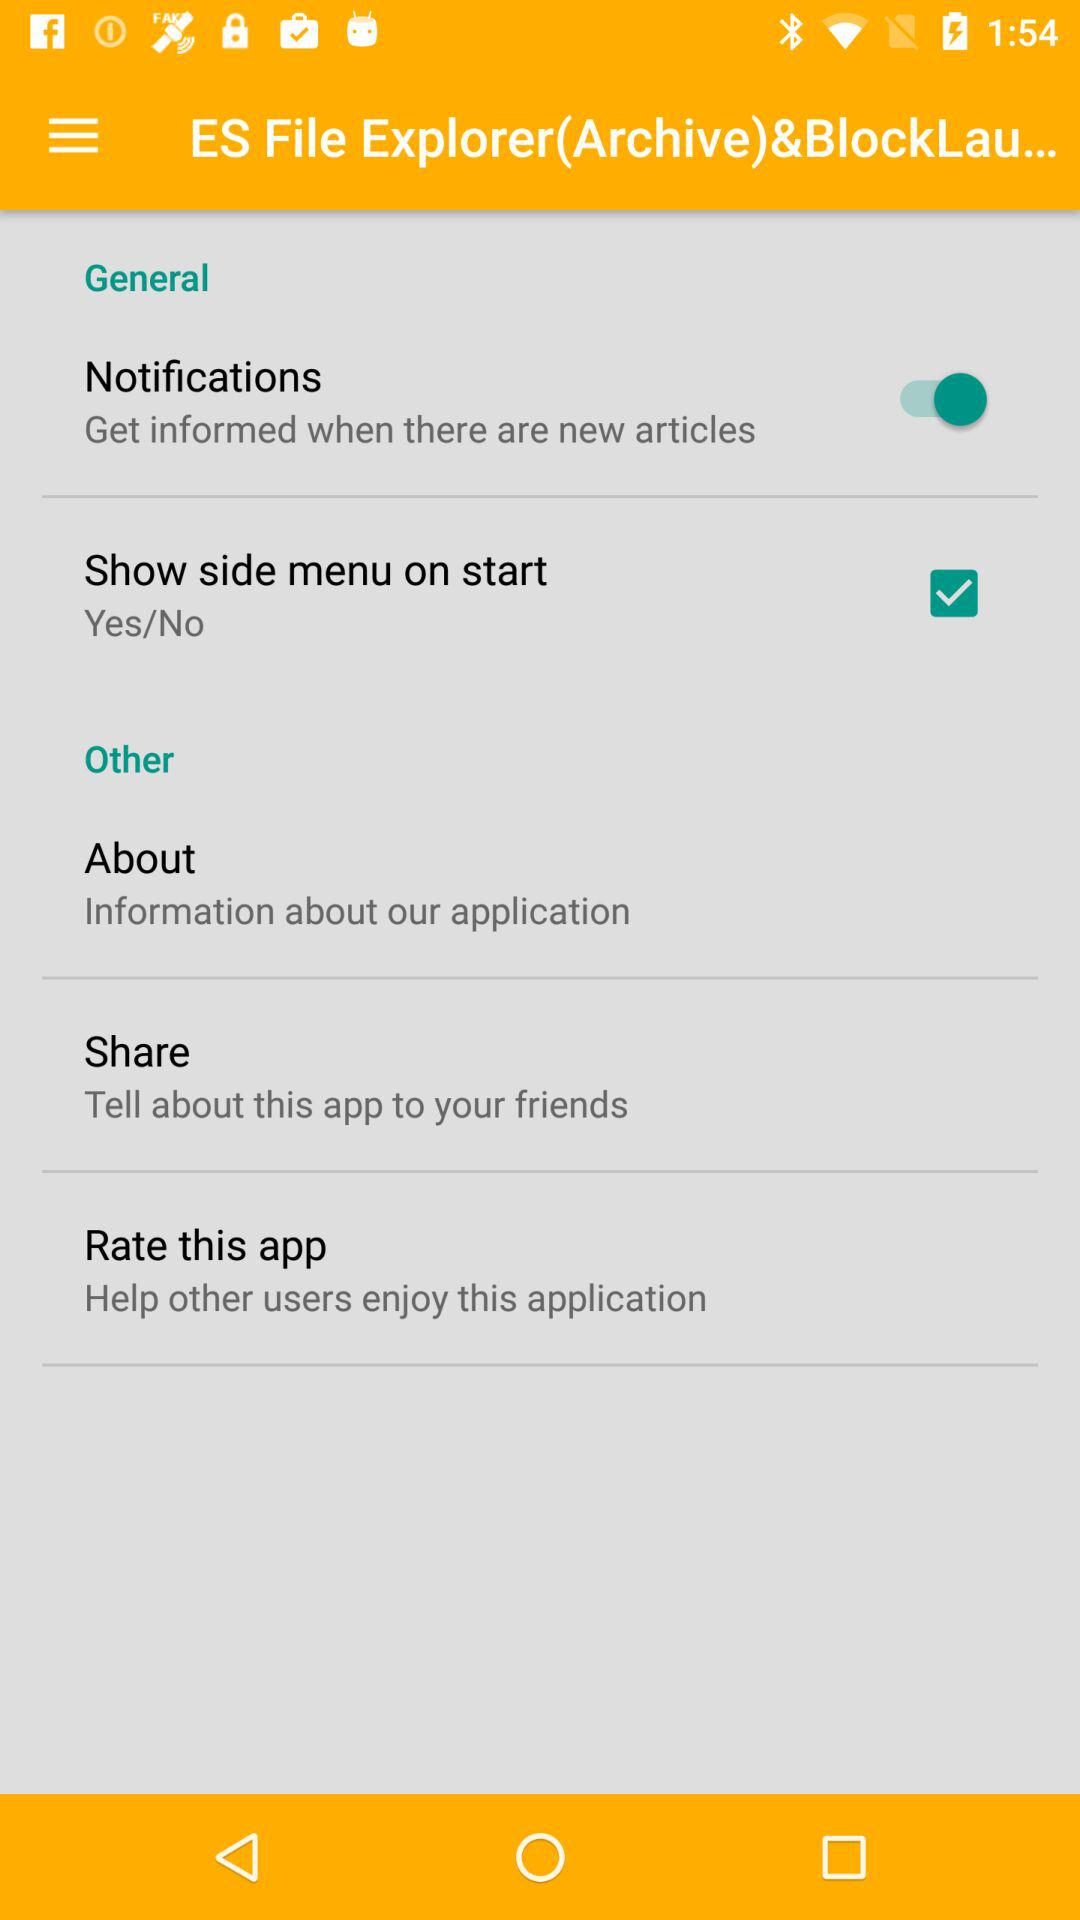What is the status of the "Show side menu on start"? The status is "on". 